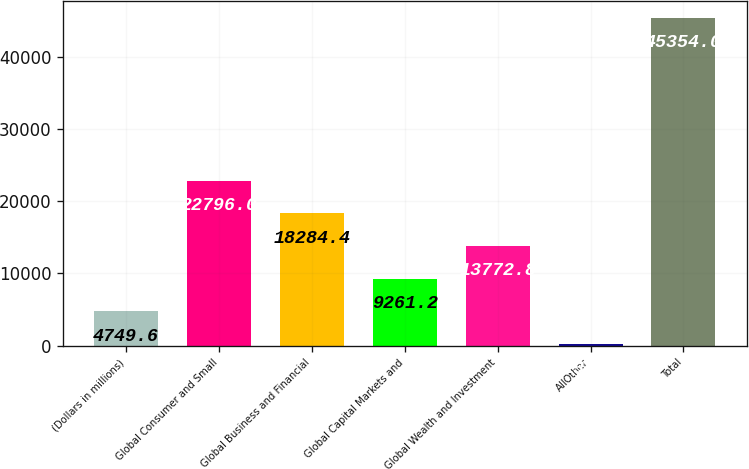Convert chart. <chart><loc_0><loc_0><loc_500><loc_500><bar_chart><fcel>(Dollars in millions)<fcel>Global Consumer and Small<fcel>Global Business and Financial<fcel>Global Capital Markets and<fcel>Global Wealth and Investment<fcel>AllOther<fcel>Total<nl><fcel>4749.6<fcel>22796<fcel>18284.4<fcel>9261.2<fcel>13772.8<fcel>238<fcel>45354<nl></chart> 